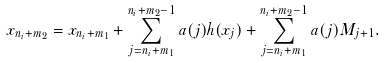<formula> <loc_0><loc_0><loc_500><loc_500>x _ { n _ { i } + m _ { 2 } } = x _ { n _ { i } + m _ { 1 } } + \sum _ { j = n _ { i } + m _ { 1 } } ^ { n _ { i } + m _ { 2 } - 1 } a ( j ) h ( x _ { j } ) + \sum _ { j = n _ { i } + m _ { 1 } } ^ { n _ { i } + m _ { 2 } - 1 } a ( j ) M _ { j + 1 } .</formula> 